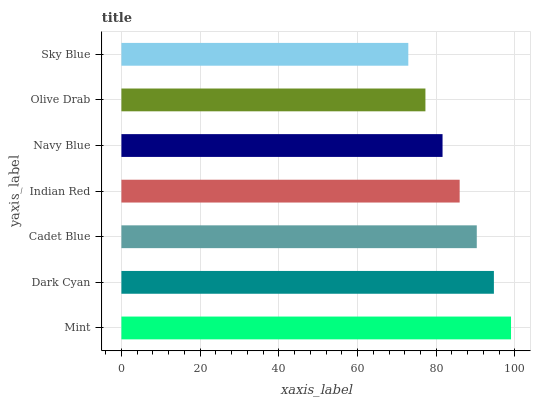Is Sky Blue the minimum?
Answer yes or no. Yes. Is Mint the maximum?
Answer yes or no. Yes. Is Dark Cyan the minimum?
Answer yes or no. No. Is Dark Cyan the maximum?
Answer yes or no. No. Is Mint greater than Dark Cyan?
Answer yes or no. Yes. Is Dark Cyan less than Mint?
Answer yes or no. Yes. Is Dark Cyan greater than Mint?
Answer yes or no. No. Is Mint less than Dark Cyan?
Answer yes or no. No. Is Indian Red the high median?
Answer yes or no. Yes. Is Indian Red the low median?
Answer yes or no. Yes. Is Olive Drab the high median?
Answer yes or no. No. Is Cadet Blue the low median?
Answer yes or no. No. 